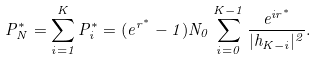<formula> <loc_0><loc_0><loc_500><loc_500>P _ { N } ^ { * } = \sum _ { i = 1 } ^ { K } P _ { i } ^ { * } = ( e ^ { r ^ { * } } - 1 ) N _ { 0 } \sum _ { i = 0 } ^ { K - 1 } \frac { e ^ { i r ^ { * } } } { | h _ { K - i } | ^ { 2 } } .</formula> 